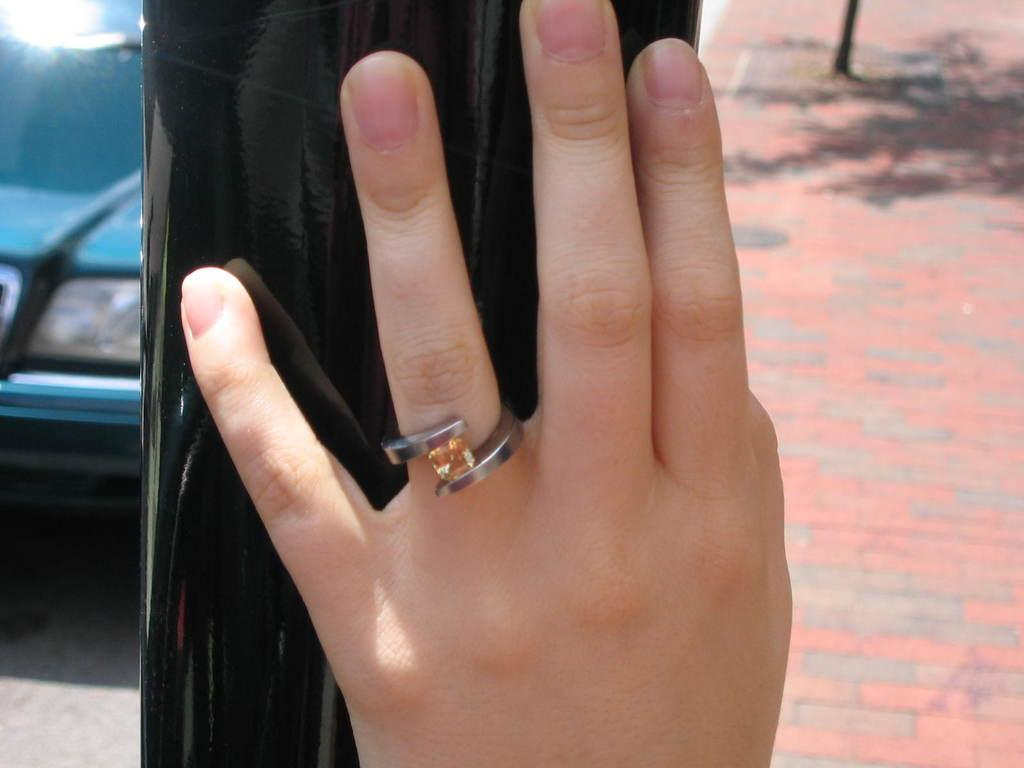What can be seen in the image involving a person's hand? There is a person's hand in the image, and it is touching a pole and a ring. Can you describe the describe the ring in the image? The ring is on a finger in the image. What is visible in the background of the image? There is a car and a sidewalk in the background of the image. Where is the car located in the image? The car is on the left side of the image. What type of lettuce is being used as a wheel in the image? There is no lettuce or wheel present in the image. Can you compare the size of the ring to the size of the car in the image? The size of the ring cannot be compared to the size of the car in the image, as they are not in the same scale or context. 